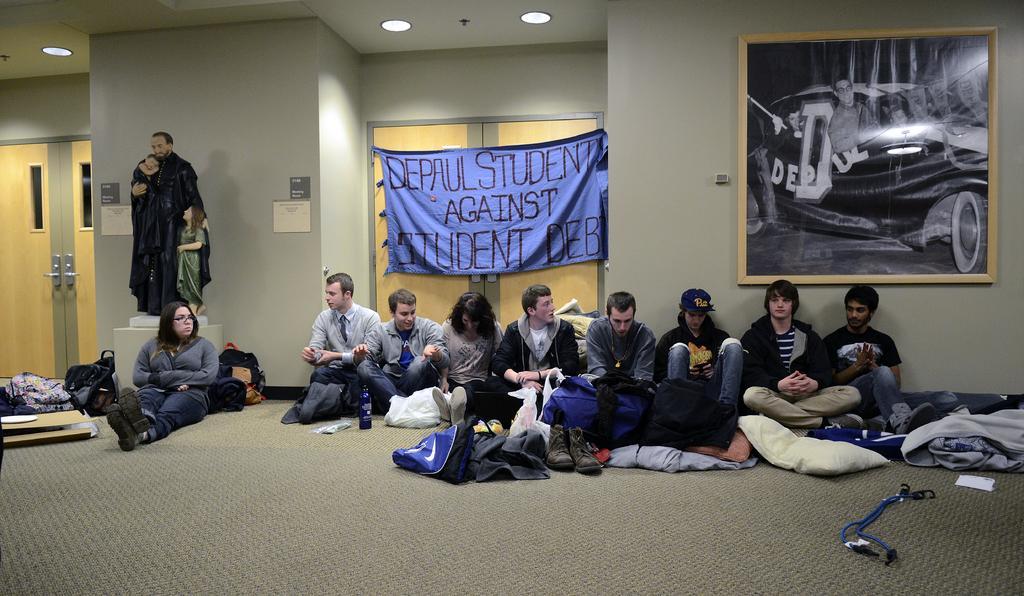Describe this image in one or two sentences. Here we can see few persons are sitting on the floor. There are bags, bottle, plastic covers, clothes, pillars, and shoes. There is a sculpture. Here we can see doors, boards, frame, and a banner. In the background we can see wall and lights. 